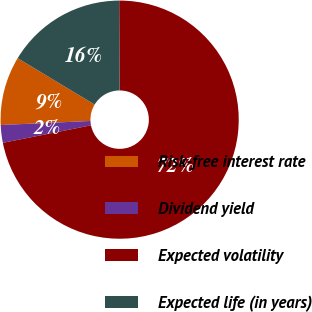Convert chart. <chart><loc_0><loc_0><loc_500><loc_500><pie_chart><fcel>Risk-free interest rate<fcel>Dividend yield<fcel>Expected volatility<fcel>Expected life (in years)<nl><fcel>9.35%<fcel>2.4%<fcel>71.94%<fcel>16.31%<nl></chart> 